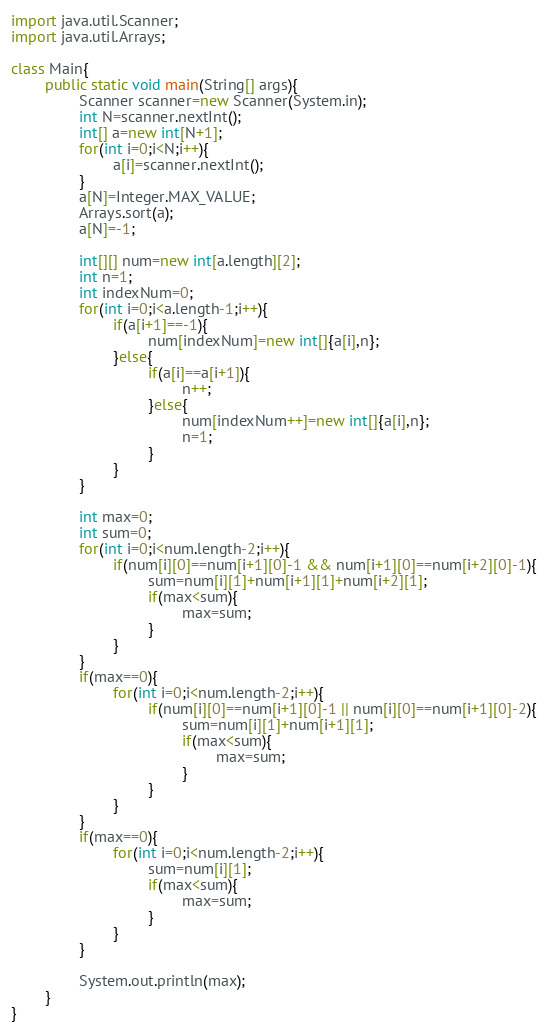<code> <loc_0><loc_0><loc_500><loc_500><_Java_>
import java.util.Scanner;
import java.util.Arrays;

class Main{
        public static void main(String[] args){
                Scanner scanner=new Scanner(System.in);
                int N=scanner.nextInt();
                int[] a=new int[N+1];
                for(int i=0;i<N;i++){
                        a[i]=scanner.nextInt();
                }
                a[N]=Integer.MAX_VALUE;
                Arrays.sort(a);
                a[N]=-1;

                int[][] num=new int[a.length][2];
                int n=1;
                int indexNum=0;
                for(int i=0;i<a.length-1;i++){
                        if(a[i+1]==-1){
                                num[indexNum]=new int[]{a[i],n};
                        }else{
                                if(a[i]==a[i+1]){
                                        n++;
                                }else{
                                        num[indexNum++]=new int[]{a[i],n};
                                        n=1;
                                }
                        }
                }

                int max=0;
                int sum=0;
                for(int i=0;i<num.length-2;i++){
                        if(num[i][0]==num[i+1][0]-1 && num[i+1][0]==num[i+2][0]-1){
                                sum=num[i][1]+num[i+1][1]+num[i+2][1];
                                if(max<sum){
                                        max=sum;
                                }
                        }
                }
                if(max==0){
                        for(int i=0;i<num.length-2;i++){
                                if(num[i][0]==num[i+1][0]-1 || num[i][0]==num[i+1][0]-2){
                                        sum=num[i][1]+num[i+1][1];
                                        if(max<sum){
                                                max=sum;
                                        }
                                }
                        }
                }
                if(max==0){
                        for(int i=0;i<num.length-2;i++){
                                sum=num[i][1];
                                if(max<sum){
                                        max=sum;
                                }
                        }
                }

                System.out.println(max);
        }
}</code> 